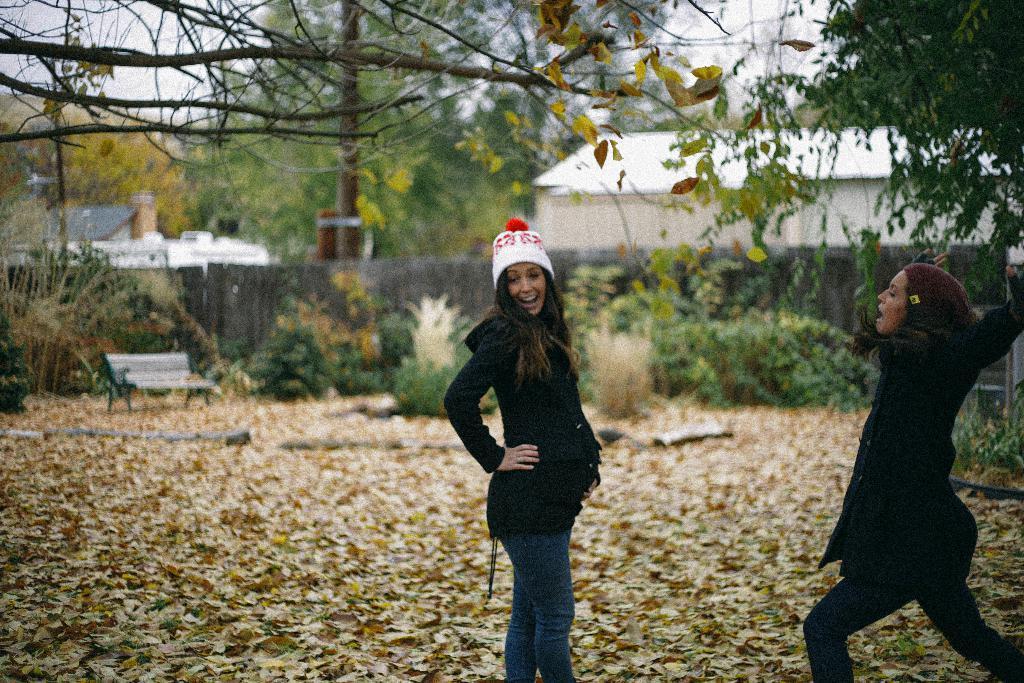Describe this image in one or two sentences. In the foreground of the image there are two ladies wearing jacket. At the bottom of the image there are leaves. In the background of the image there are houses, trees, bench and fencing. 